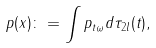Convert formula to latex. <formula><loc_0><loc_0><loc_500><loc_500>p ( x ) \colon = \int { p _ { t \omega } d \tau _ { 2 l } ( t ) } ,</formula> 